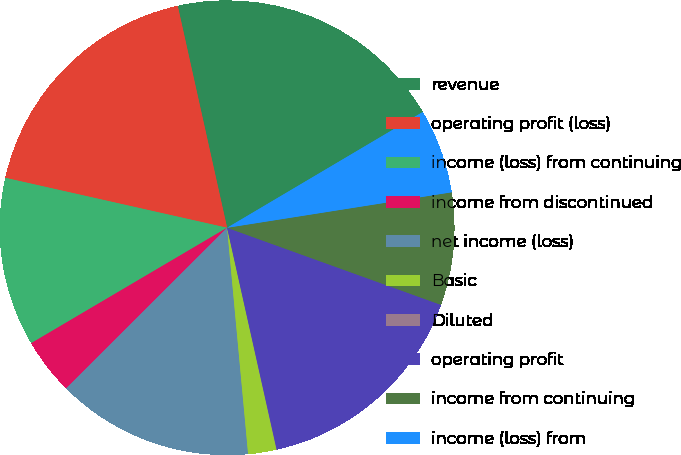Convert chart to OTSL. <chart><loc_0><loc_0><loc_500><loc_500><pie_chart><fcel>revenue<fcel>operating profit (loss)<fcel>income (loss) from continuing<fcel>income from discontinued<fcel>net income (loss)<fcel>Basic<fcel>Diluted<fcel>operating profit<fcel>income from continuing<fcel>income (loss) from<nl><fcel>19.98%<fcel>17.99%<fcel>12.0%<fcel>4.01%<fcel>13.99%<fcel>2.01%<fcel>0.02%<fcel>15.99%<fcel>8.0%<fcel>6.01%<nl></chart> 